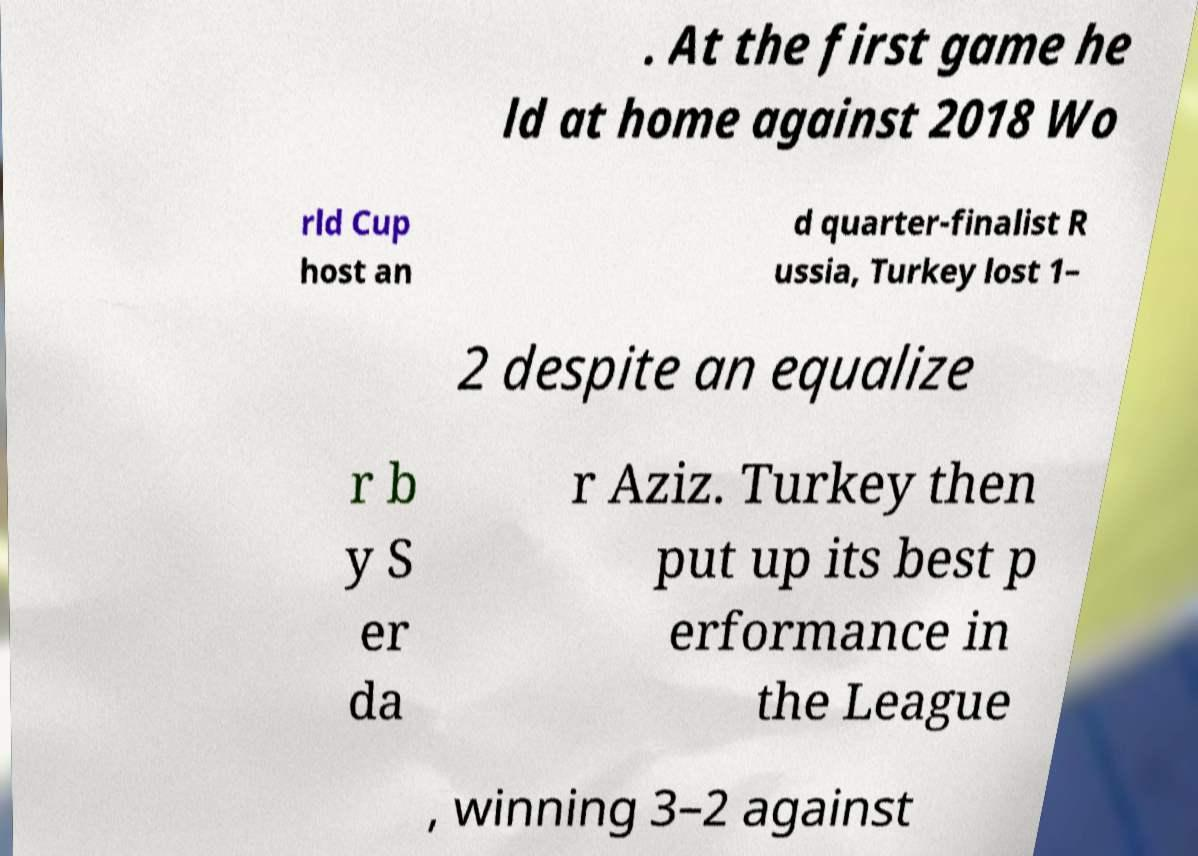I need the written content from this picture converted into text. Can you do that? . At the first game he ld at home against 2018 Wo rld Cup host an d quarter-finalist R ussia, Turkey lost 1– 2 despite an equalize r b y S er da r Aziz. Turkey then put up its best p erformance in the League , winning 3–2 against 